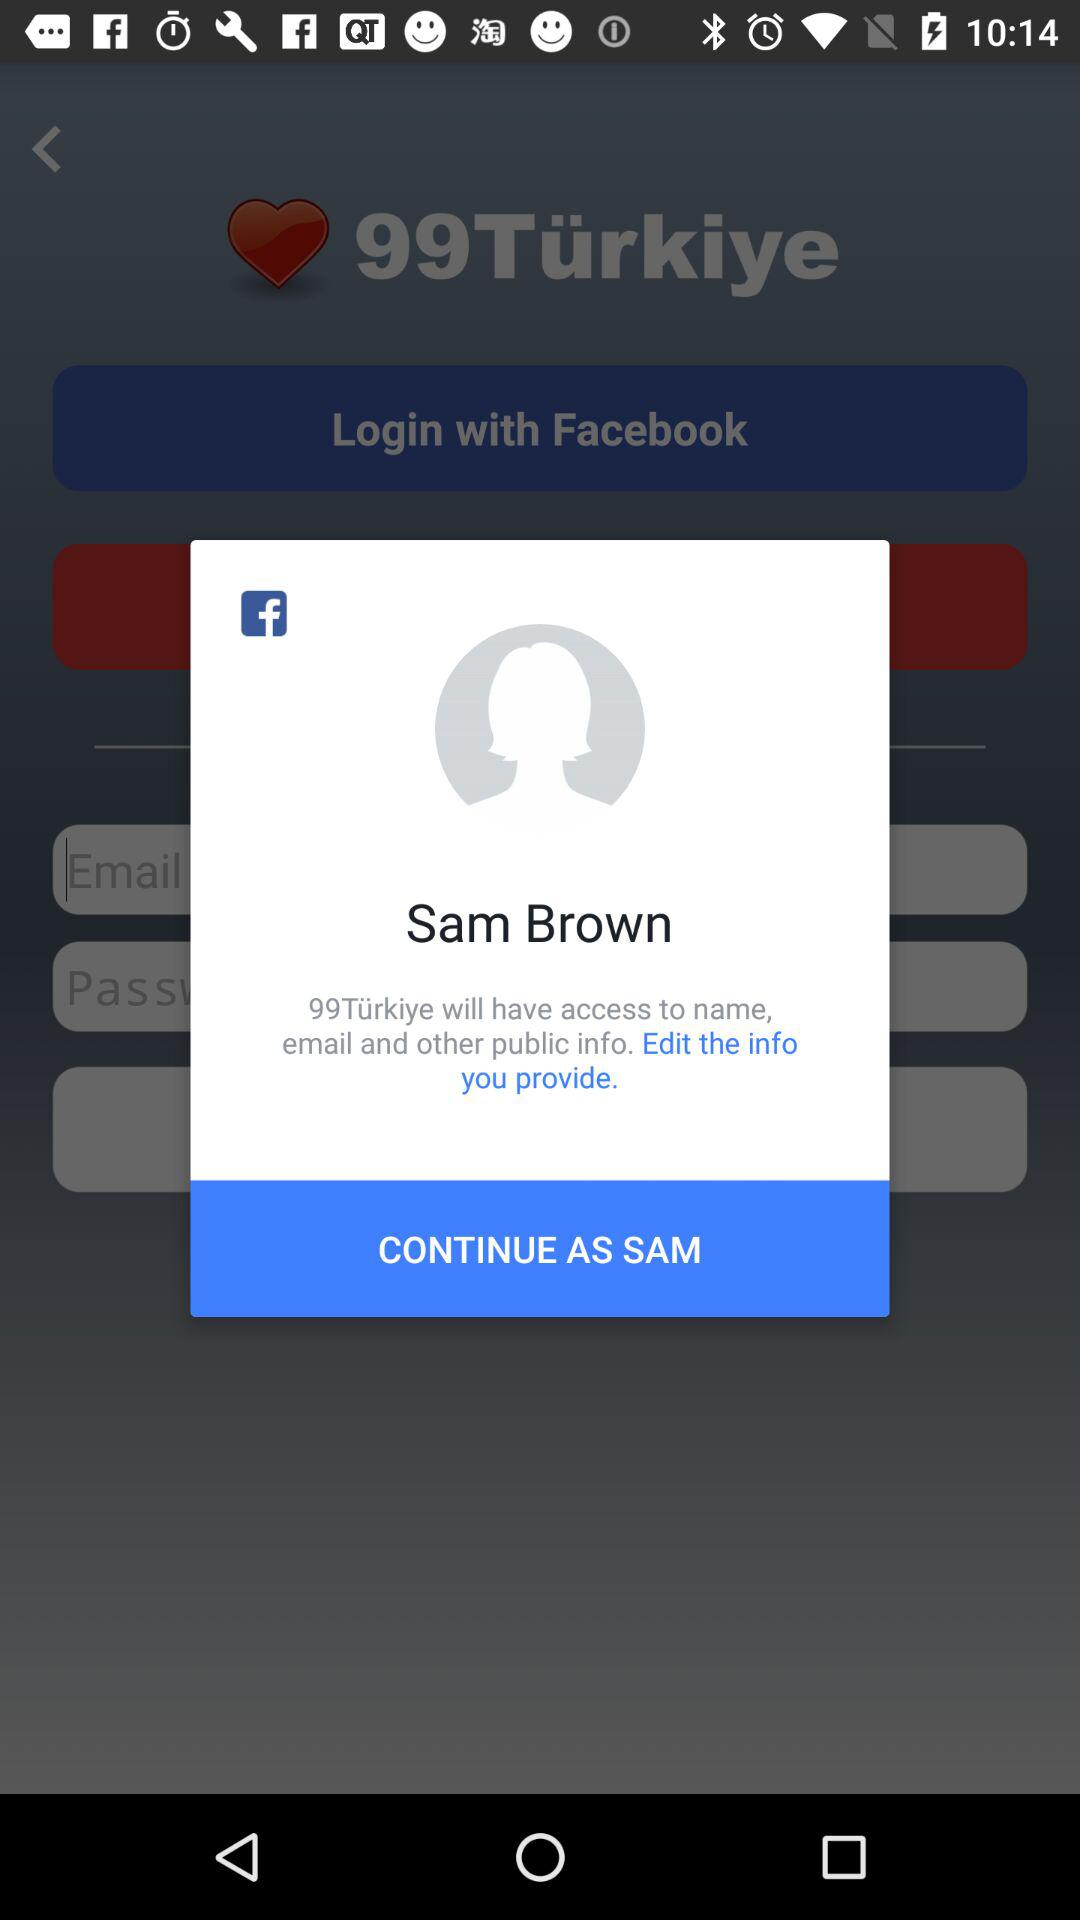What's the name of the user by whom the application can be continued? The name of the user is Sam Brown. 